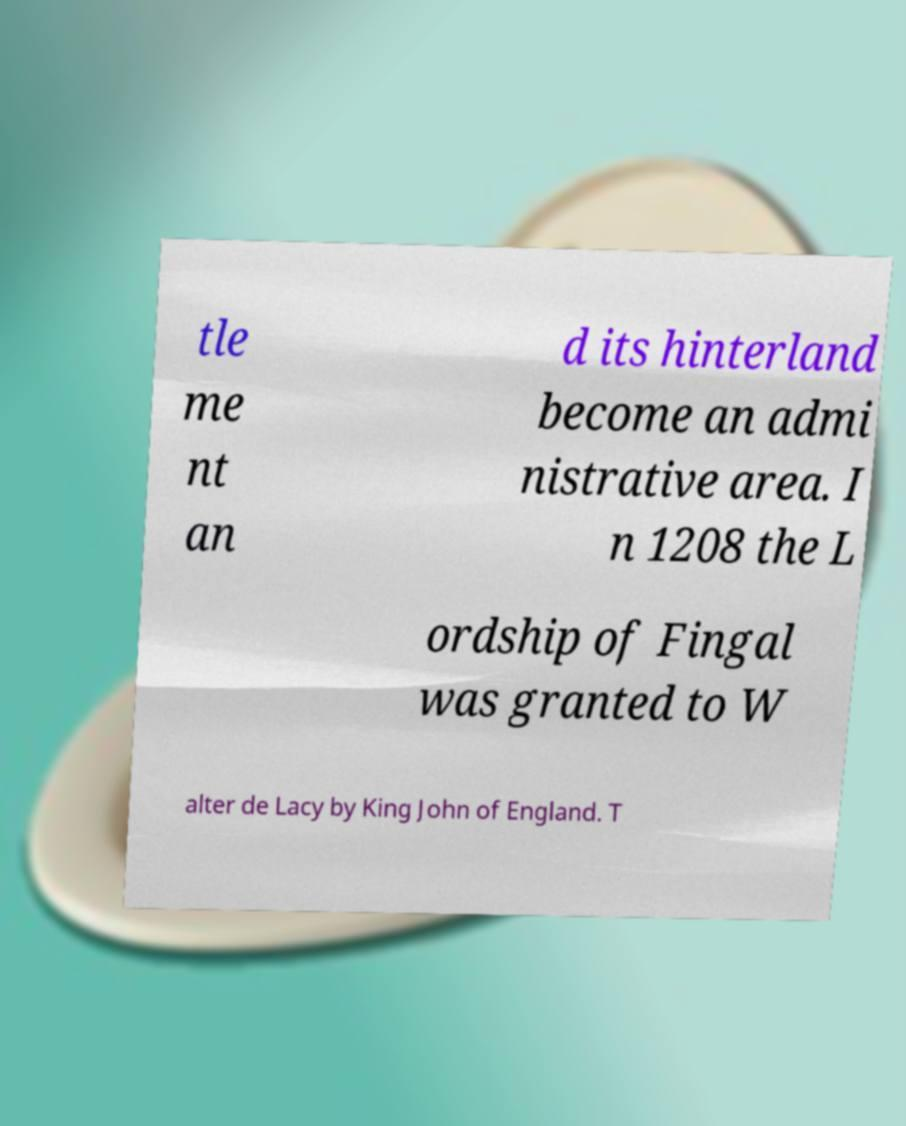Please read and relay the text visible in this image. What does it say? tle me nt an d its hinterland become an admi nistrative area. I n 1208 the L ordship of Fingal was granted to W alter de Lacy by King John of England. T 